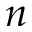<formula> <loc_0><loc_0><loc_500><loc_500>n</formula> 